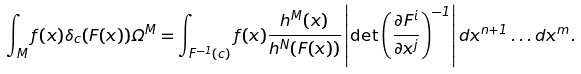<formula> <loc_0><loc_0><loc_500><loc_500>\int _ { M } f ( x ) \delta _ { c } ( F ( x ) ) \Omega ^ { M } = \int _ { F ^ { - 1 } ( c ) } f ( x ) \frac { h ^ { M } ( x ) } { h ^ { N } ( F ( x ) ) } \left | \det \left ( \frac { \partial F ^ { i } } { \partial x ^ { j } } \right ) ^ { - 1 } \right | d x ^ { n + 1 } \dots d x ^ { m } .</formula> 